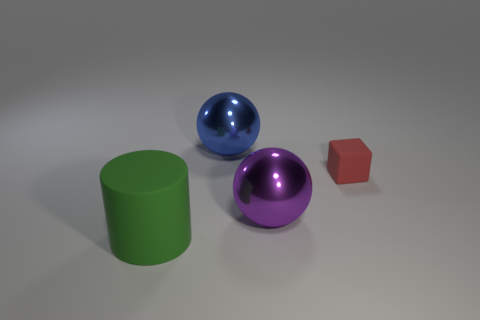Imagine if these objects were part of a children's game, what kind of game could it be? These objects might be part of a sorting or matching game where children are asked to group them by color or shape. The spheres, cylinder, and cube could also serve as pieces in a simple physical puzzle, where the goal is to return them to corresponding shaped and colored outlines on a board. 